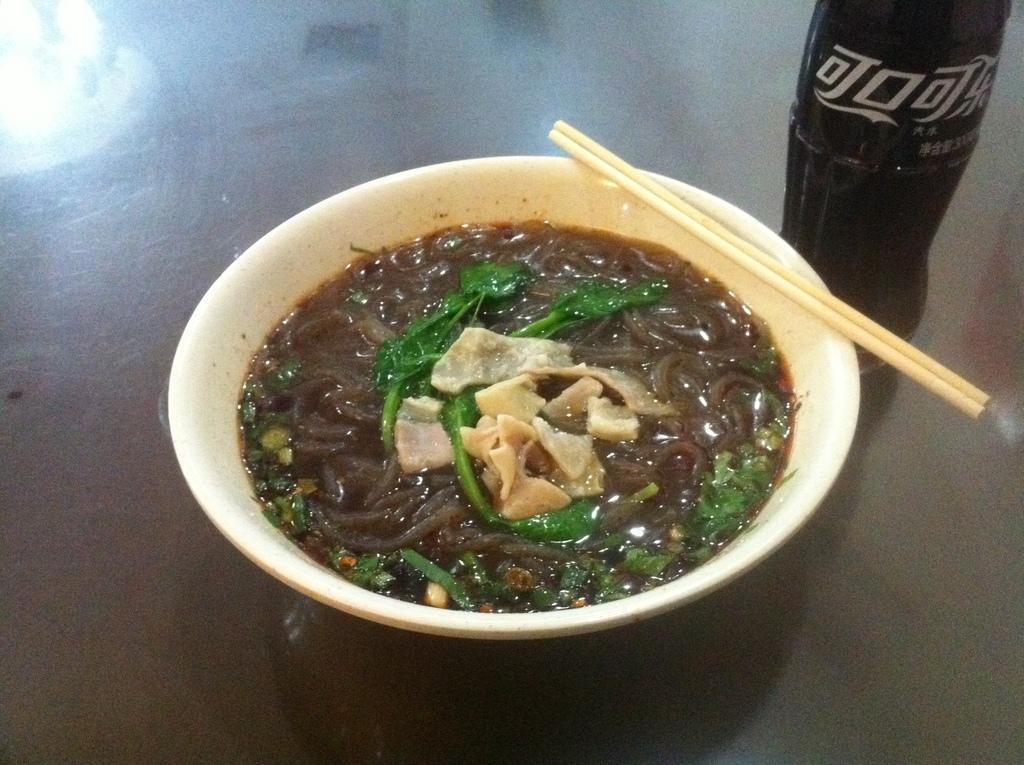In one or two sentences, can you explain what this image depicts? In the center of the image there is a bowl with food items in it. There are two sticks. To the right side of the image there is a coke bottle. At the bottom of the image there is table. 